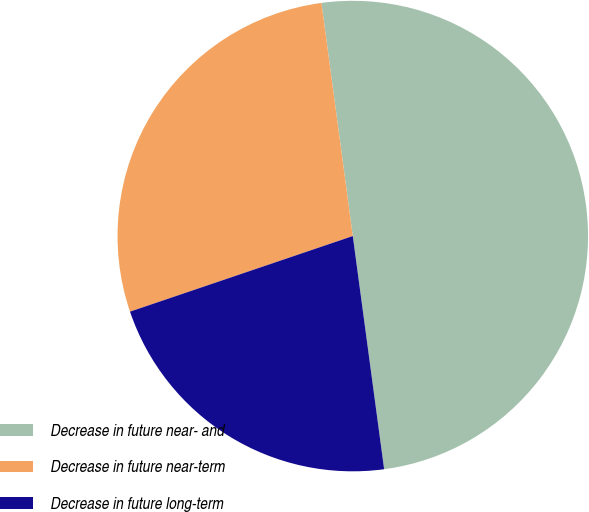<chart> <loc_0><loc_0><loc_500><loc_500><pie_chart><fcel>Decrease in future near- and<fcel>Decrease in future near-term<fcel>Decrease in future long-term<nl><fcel>50.0%<fcel>28.08%<fcel>21.92%<nl></chart> 